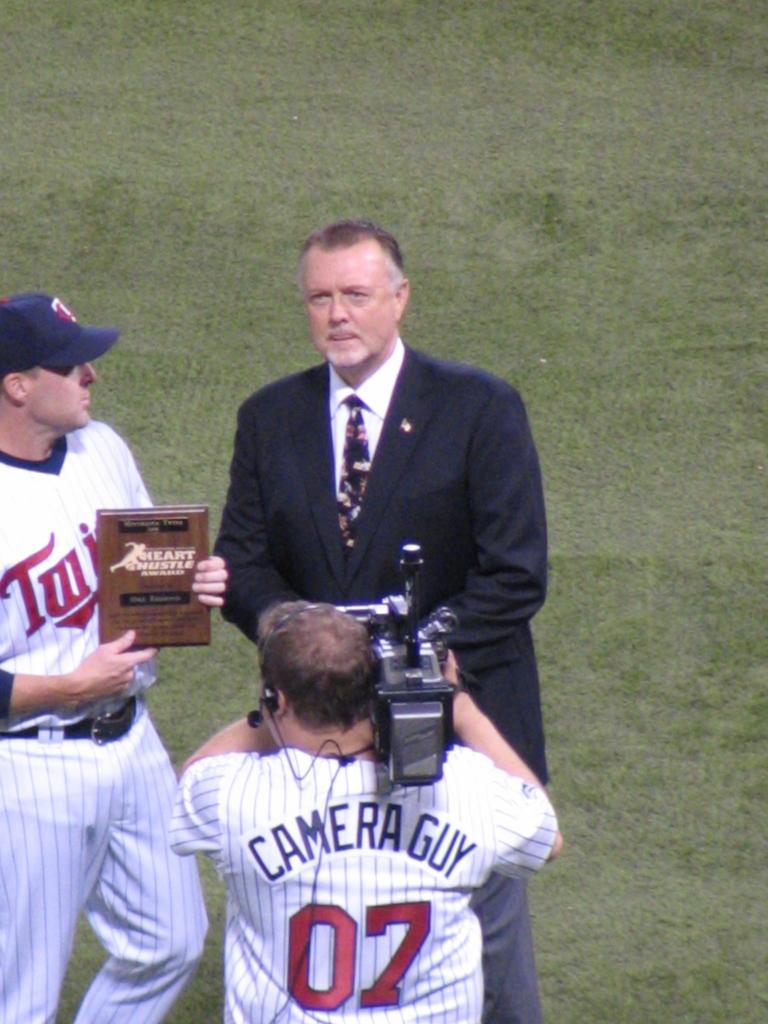What is the guy's name?
Your answer should be very brief. Camera guy. What team do they play for?
Offer a terse response. Twins. 